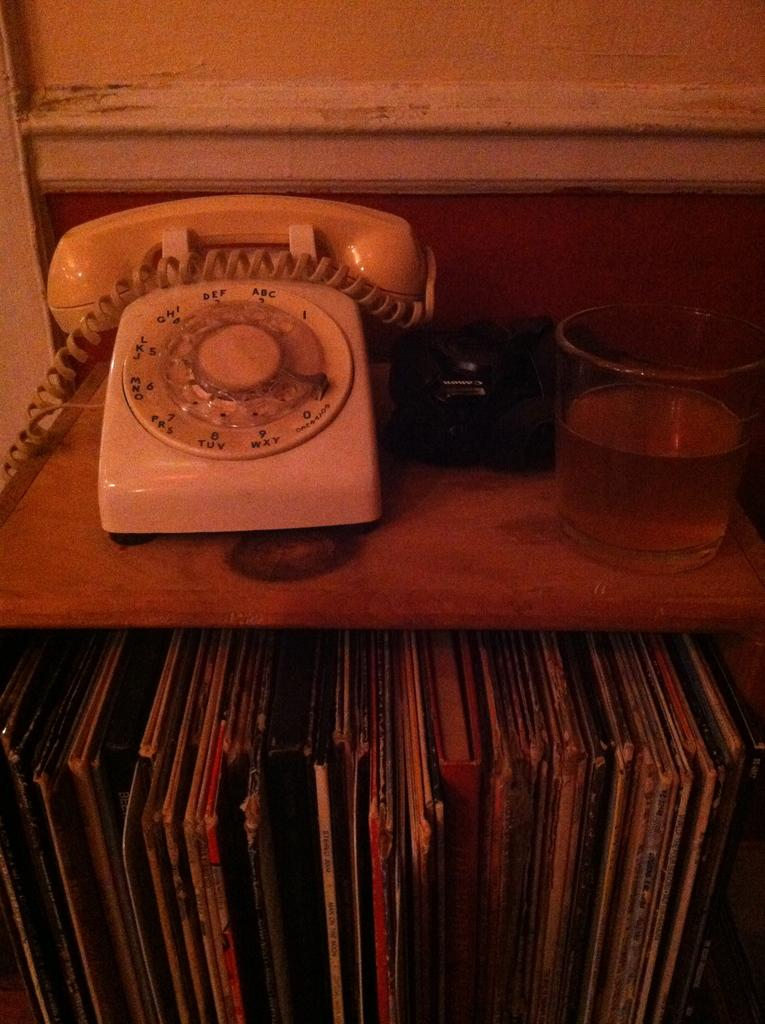<image>
Render a clear and concise summary of the photo. a phone that has the number 2 on it 